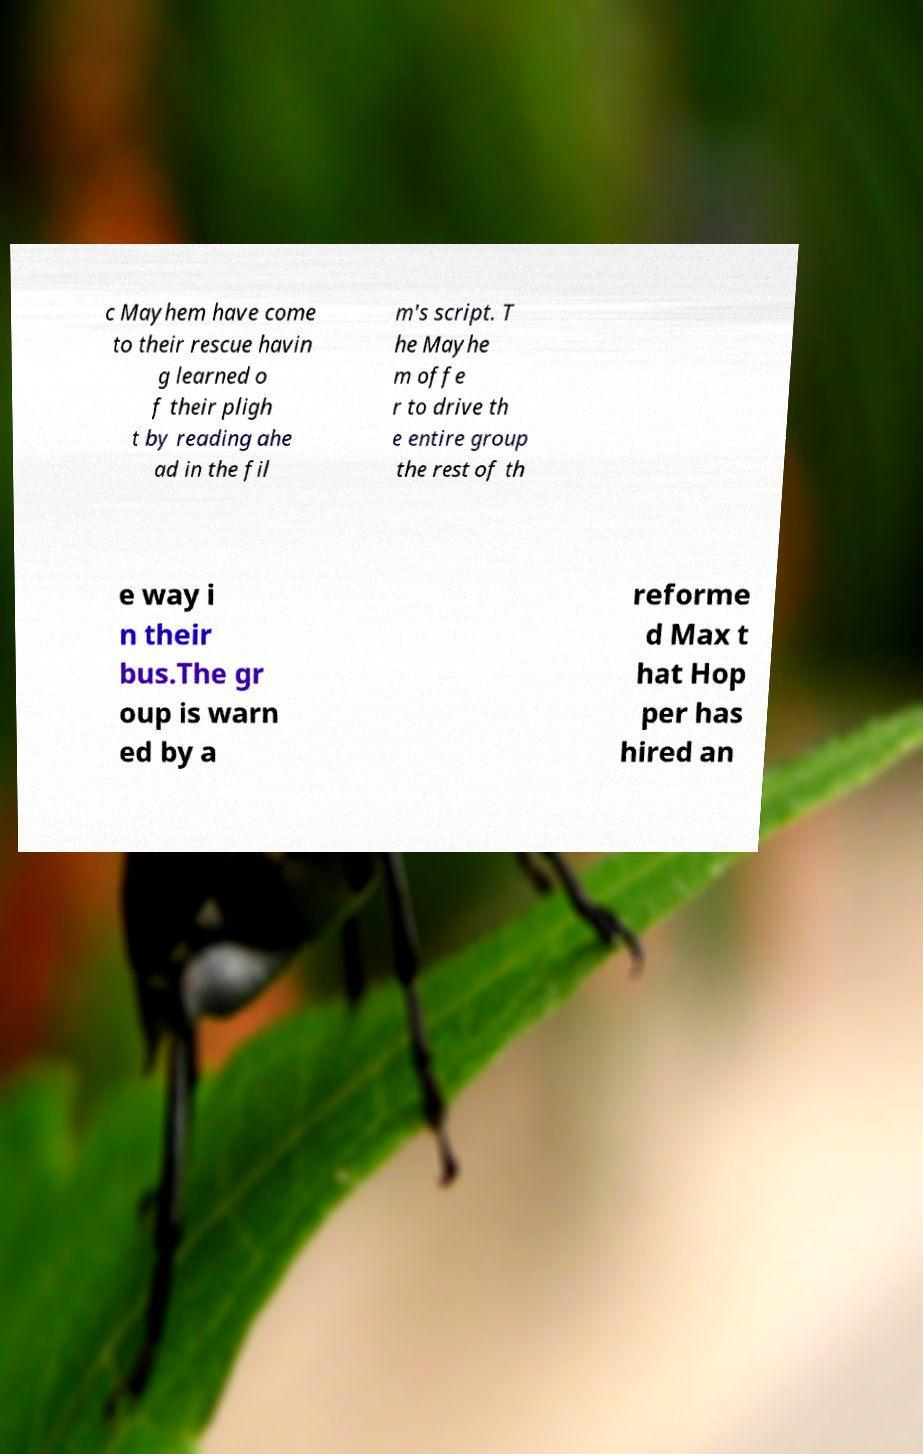I need the written content from this picture converted into text. Can you do that? c Mayhem have come to their rescue havin g learned o f their pligh t by reading ahe ad in the fil m's script. T he Mayhe m offe r to drive th e entire group the rest of th e way i n their bus.The gr oup is warn ed by a reforme d Max t hat Hop per has hired an 